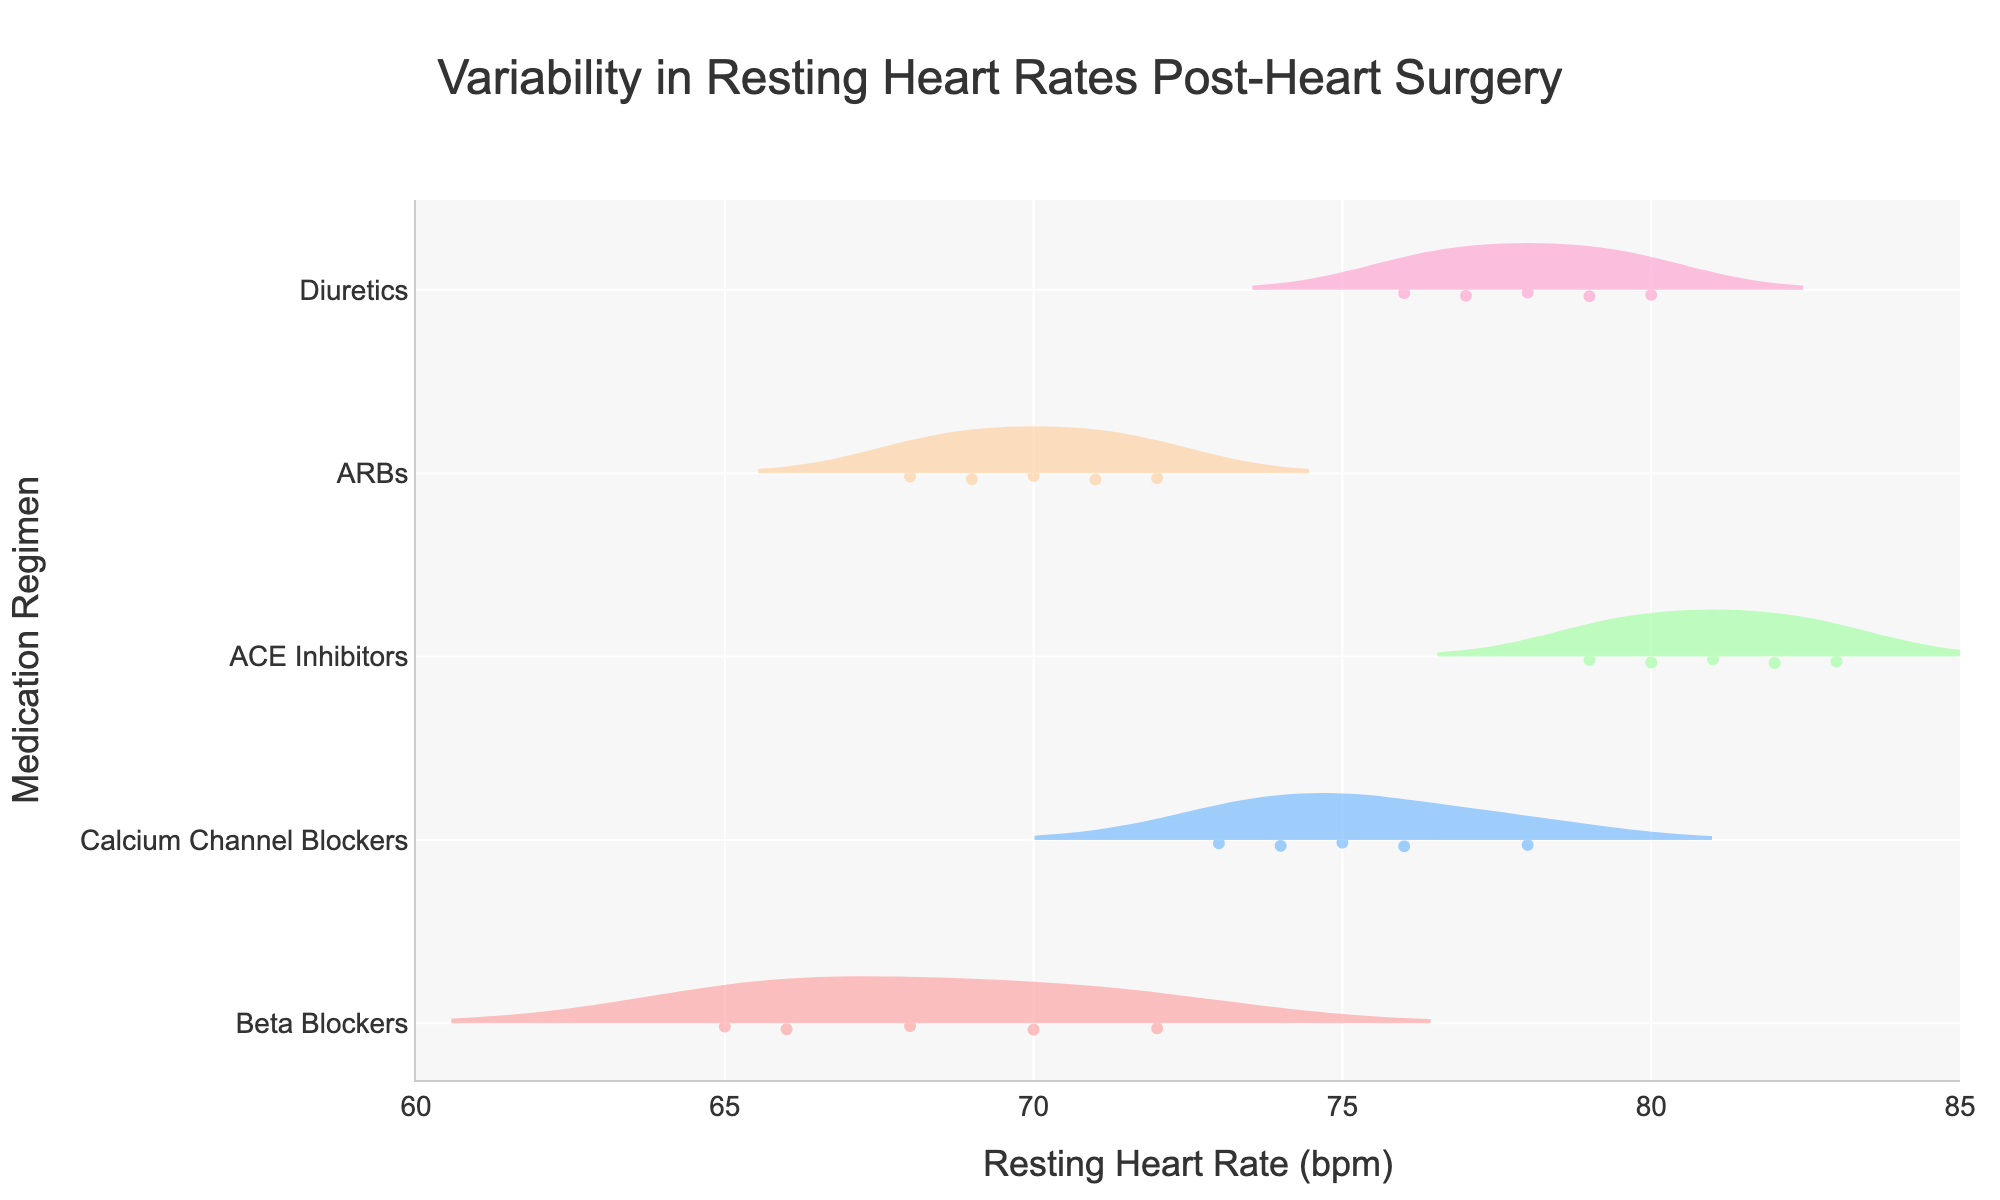What is the title of the figure? The title is located at the top of the figure and reads "Variability in Resting Heart Rates Post-Heart Surgery".
Answer: Variability in Resting Heart Rates Post-Heart Surgery What is the range of the x-axis? The x-axis represents the resting heart rate in beats per minute (bpm) and ranges from 60 to 85 bpm.
Answer: 60 to 85 bpm Which medication regimen has the highest mean resting heart rate? The mean resting heart rate is indicated by the mean line within each violin plot. The mean line is highest for the ACE Inhibitors group.
Answer: ACE Inhibitors How many data points are there for the Beta Blockers group? The Beta Blockers group has points plotted within their violin plot. Counting these points gives a total of 5 data points.
Answer: 5 Which group has a wider spread in resting heart rates, Calcium Channel Blockers or ARBs? The spread or variability is indicated by the width of the violin plot. Calcium Channel Blockers show a wider spread compared to ARBs.
Answer: Calcium Channel Blockers What's the median resting heart rate for the Diuretics group? The median is shown in the center of each violin plot. For Diuretics, it is 78 bpm.
Answer: 78 bpm Are there any medication regimens where all data points fall below 75 bpm? We need to check the individual points within each violin plot. All points for Beta Blockers and ARBs fall below 75 bpm.
Answer: Beta Blockers and ARBs Compare the average resting heart rates of Beta Blockers and Calcium Channel Blockers. The average resting heart rates can be inferred from the mean lines in the violin plots. Beta Blockers have a lower mean heart rate compared to Calcium Channel Blockers.
Answer: Beta Blockers < Calcium Channel Blockers What is the Resting Heart Rate range for ACE Inhibitors? The range can be seen from the endpoints of the violin plot for ACE Inhibitors. It spans from approximately 79 to 83 bpm.
Answer: 79 to 83 bpm Which medication regimen has the most consistent resting heart rates? Consistency can be interpreted as the least spread. Beta Blockers have the narrowest spread, indicating the most consistent resting heart rates.
Answer: Beta Blockers 